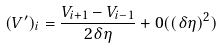Convert formula to latex. <formula><loc_0><loc_0><loc_500><loc_500>( V ^ { \prime } ) _ { i } = \frac { V _ { i + 1 } - V _ { i - 1 } } { 2 \delta \eta } + 0 ( ( \delta \eta ) ^ { 2 } )</formula> 